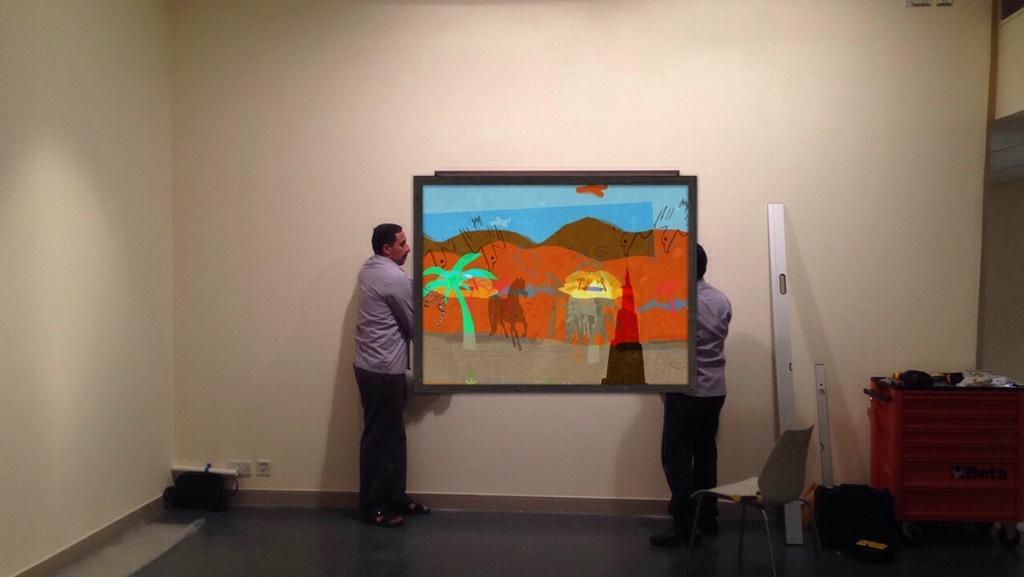Can you describe this image briefly? In the center of the image we can see a photo frame and two persons are standing on the floor. To the right side of the image we can see metal poles, chair and a container placed on the floor. In the background, we can see the wall. 